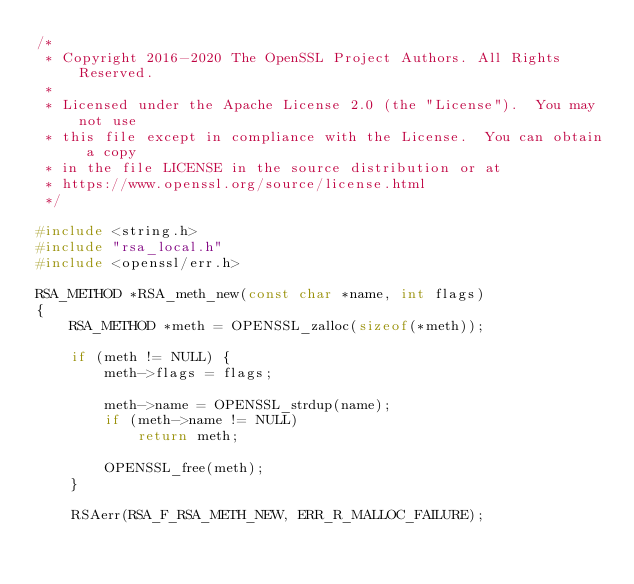<code> <loc_0><loc_0><loc_500><loc_500><_C_>/*
 * Copyright 2016-2020 The OpenSSL Project Authors. All Rights Reserved.
 *
 * Licensed under the Apache License 2.0 (the "License").  You may not use
 * this file except in compliance with the License.  You can obtain a copy
 * in the file LICENSE in the source distribution or at
 * https://www.openssl.org/source/license.html
 */

#include <string.h>
#include "rsa_local.h"
#include <openssl/err.h>

RSA_METHOD *RSA_meth_new(const char *name, int flags)
{
    RSA_METHOD *meth = OPENSSL_zalloc(sizeof(*meth));

    if (meth != NULL) {
        meth->flags = flags;

        meth->name = OPENSSL_strdup(name);
        if (meth->name != NULL)
            return meth;

        OPENSSL_free(meth);
    }

    RSAerr(RSA_F_RSA_METH_NEW, ERR_R_MALLOC_FAILURE);</code> 